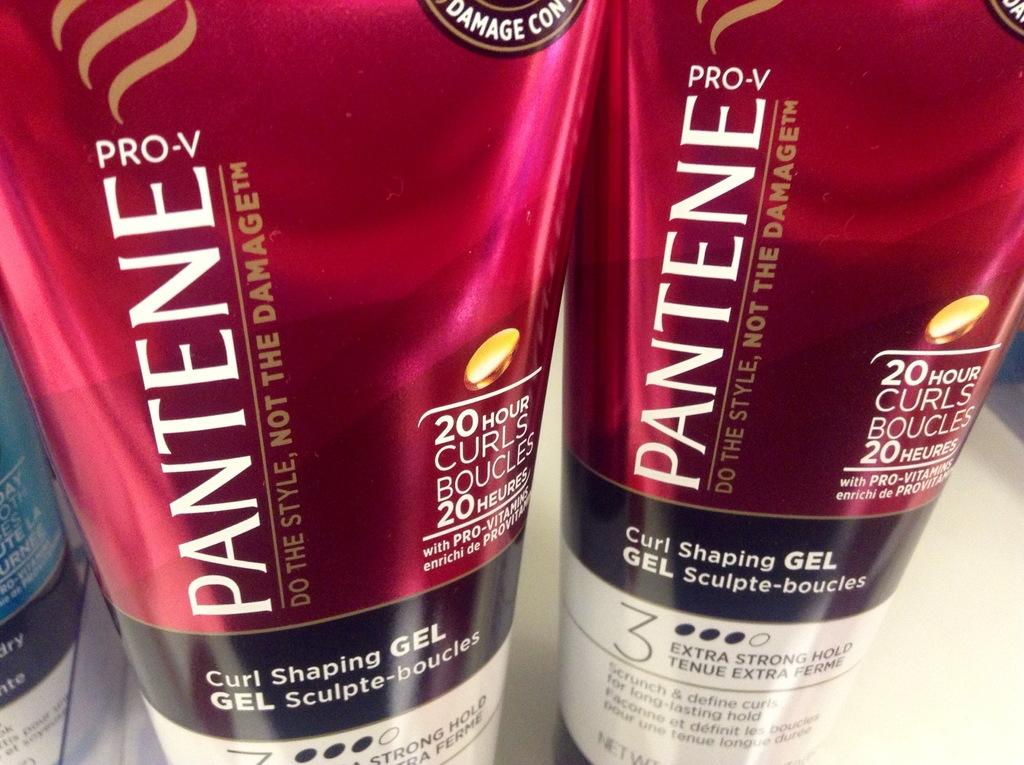<image>
Share a concise interpretation of the image provided. The tagline of the Pantene product is "Do the style, not the damage". 